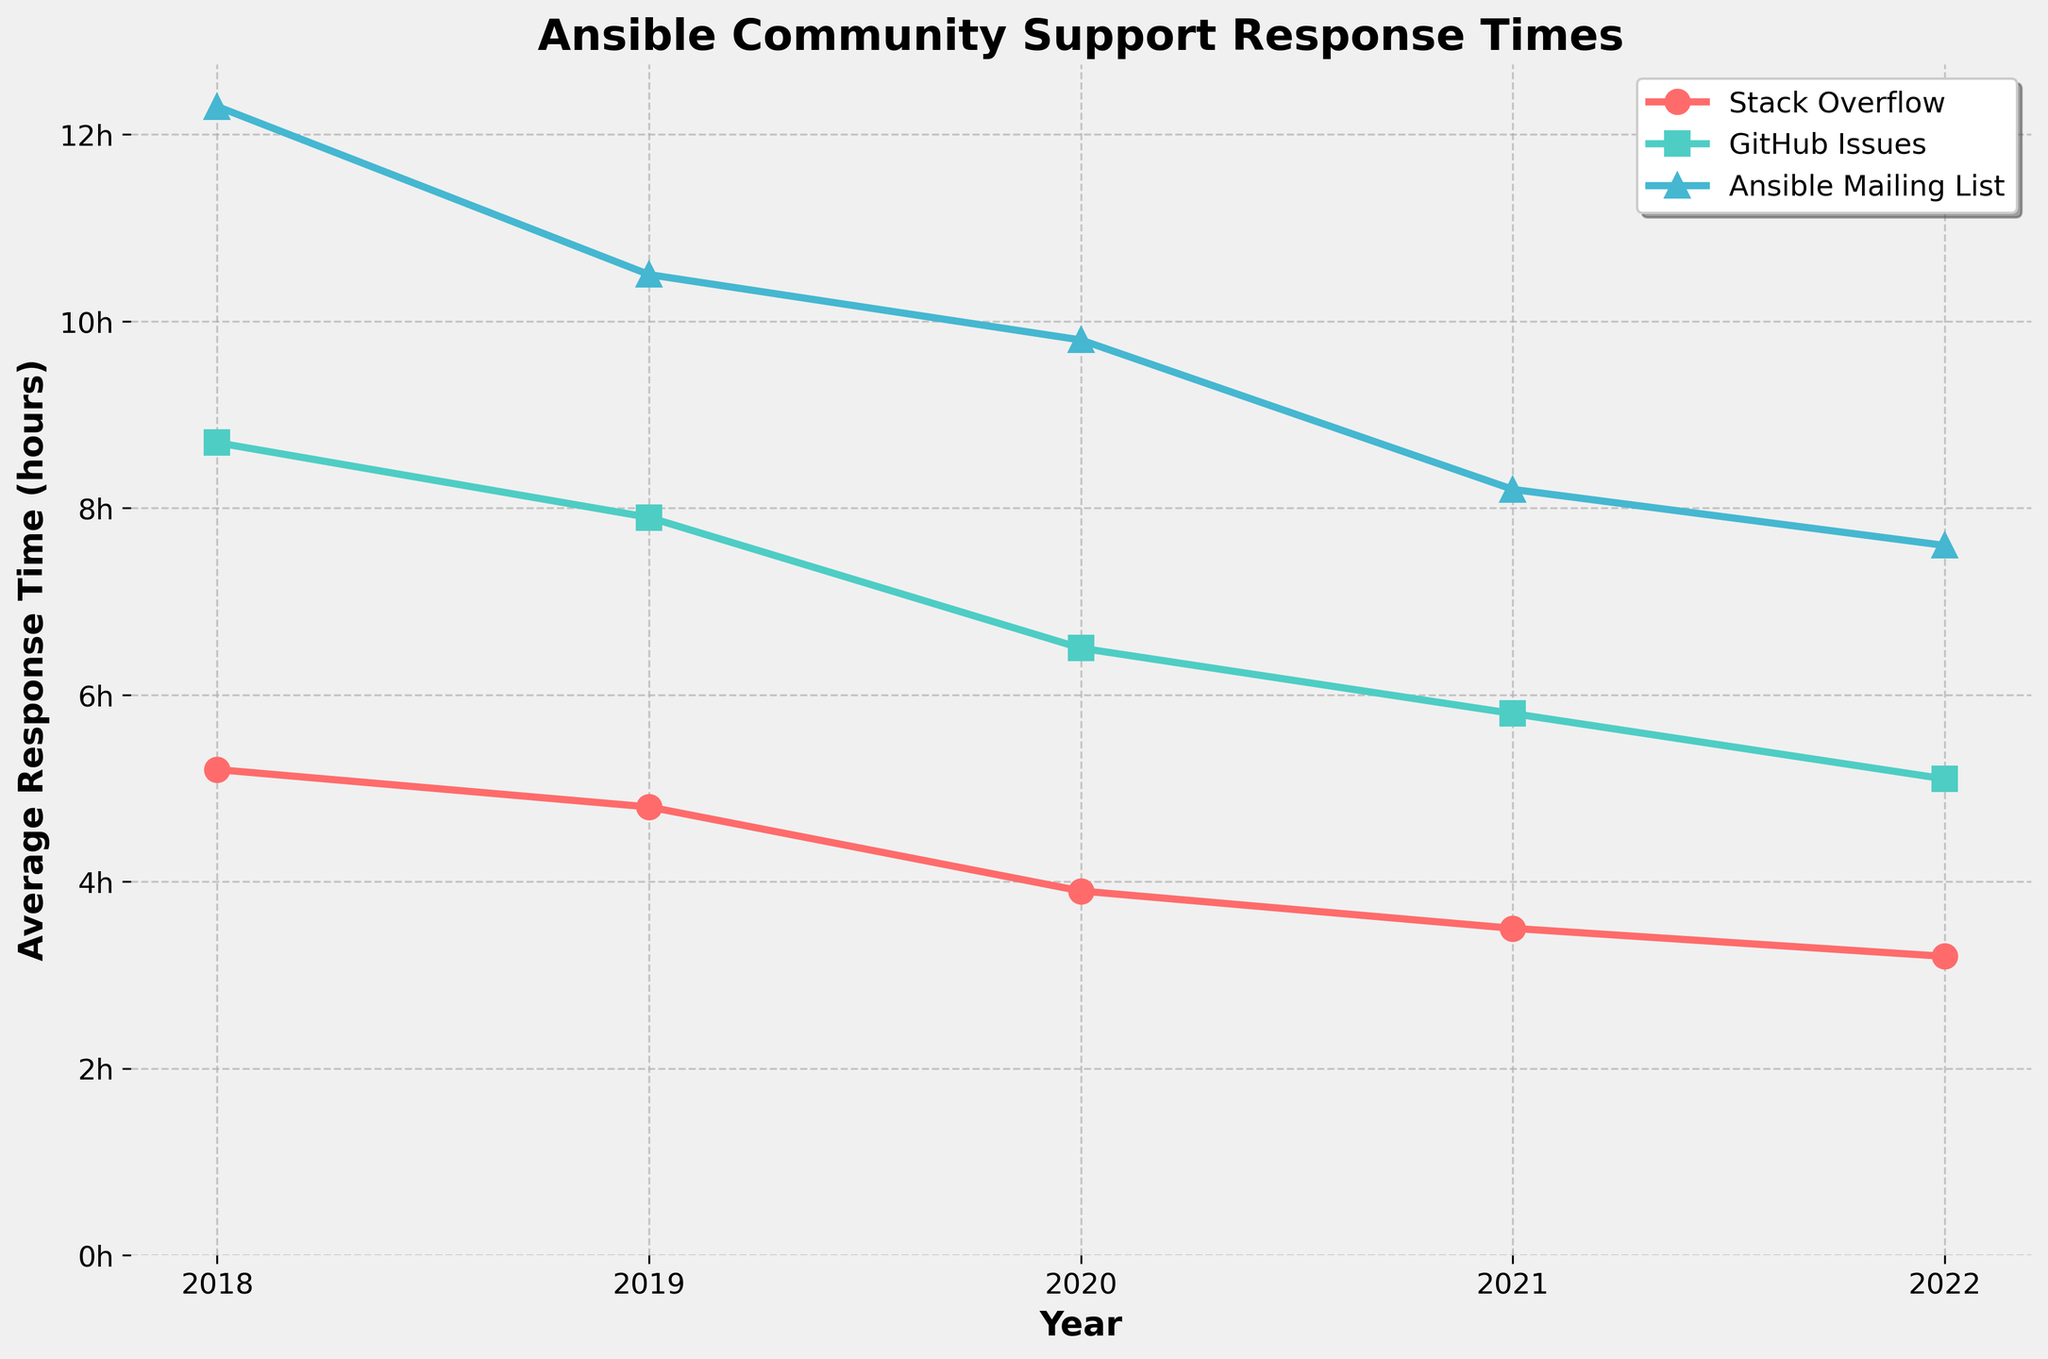What is the average response time for Stack Overflow in 2020? Look at the point corresponding to the year 2020 in the Stack Overflow series (marked with red circles). The value is 3.9 hours.
Answer: 3.9 hours Which platform had the highest response time in 2018, and what was it? In 2018, the graph shows that the Ansible Mailing List had the highest response time at 12.3 hours. This is represented by the blue triangle marker which is the highest among all three platforms for that year.
Answer: Ansible Mailing List, 12.3 hours By how much did the response time on GitHub Issues decrease from 2019 to 2022? The response time for GitHub Issues in 2019 was 7.9 hours and in 2022 it was 5.1 hours. The decrease is 7.9 - 5.1 hours = 2.8 hours.
Answer: 2.8 hours Which year saw the largest decrease in response time for the Ansible Mailing List compared to the previous year? Check the yearly decreases for the Ansible Mailing List. The largest decrease is from 2019 to 2020, going from 10.5 to 9.8 hours, a decrease of 0.7 hours. This is the largest since all the other yearly decreases are smaller.
Answer: 2019 to 2020 Which platform showed the most consistent improvement in response time over the 5 years? Compare all three plots. Stack Overflow response times follow a consistent decrease from 5.2 hours in 2018 to 3.2 hours in 2022. The trend line is smooth without any increases or stagnations.
Answer: Stack Overflow Calculate the average rate of response time improvement per year for GitHub Issues from 2018 to 2022. The initial response time for GitHub Issues in 2018 was 8.7 hours and the final in 2022 is 5.1 hours. The total decrease is 8.7 - 5.1 = 3.6 hours over 4 years, thus the average annual improvement rate is 3.6 / 4 = 0.9 hours/year.
Answer: 0.9 hours/year What are the visual indicators used to differentiate between platforms in the plot? Platforms are differentiated using color and markers. Stack Overflow uses red circles, GitHub Issues uses green squares, and Ansible Mailing List uses blue triangles. The lines connecting these markers also use corresponding colors.
Answer: Color and Markers Which platform had the smallest decrease in response time from 2021 to 2022? Check the decrease for each platform from 2021 to 2022. Stack Overflow decreased by 0.3 hours, GitHub Issues by 0.7 hours, and Ansible Mailing List by 0.6 hours. The smallest decrease is for Stack Overflow.
Answer: Stack Overflow 